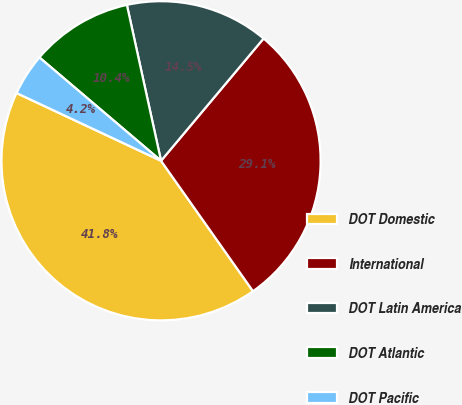Convert chart. <chart><loc_0><loc_0><loc_500><loc_500><pie_chart><fcel>DOT Domestic<fcel>International<fcel>DOT Latin America<fcel>DOT Atlantic<fcel>DOT Pacific<nl><fcel>41.76%<fcel>29.12%<fcel>14.54%<fcel>10.36%<fcel>4.23%<nl></chart> 